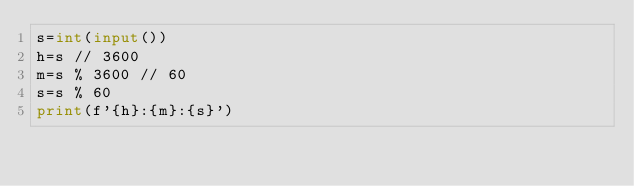<code> <loc_0><loc_0><loc_500><loc_500><_Python_>s=int(input())
h=s // 3600
m=s % 3600 // 60
s=s % 60
print(f'{h}:{m}:{s}')

</code> 